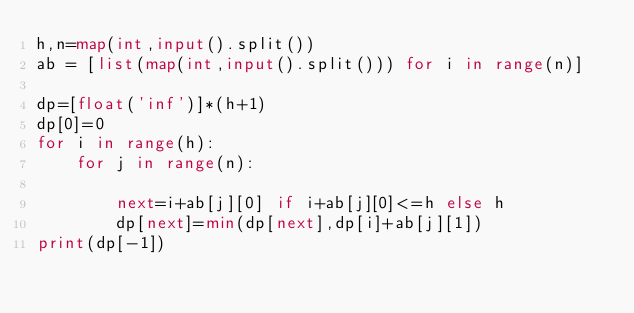Convert code to text. <code><loc_0><loc_0><loc_500><loc_500><_Python_>h,n=map(int,input().split())
ab = [list(map(int,input().split())) for i in range(n)]

dp=[float('inf')]*(h+1)
dp[0]=0
for i in range(h):
    for j in range(n):

        next=i+ab[j][0] if i+ab[j][0]<=h else h
        dp[next]=min(dp[next],dp[i]+ab[j][1])
print(dp[-1])
</code> 